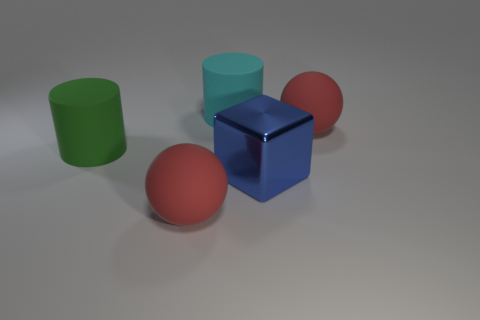There is a red sphere to the right of the big red object to the left of the blue cube; how big is it?
Offer a very short reply. Large. What color is the big thing that is right of the large cyan matte cylinder and behind the blue metal thing?
Offer a very short reply. Red. Is the shape of the green object the same as the big blue thing?
Provide a short and direct response. No. There is a matte thing that is left of the rubber ball that is in front of the block; what shape is it?
Your answer should be very brief. Cylinder. Is the shape of the cyan rubber object the same as the green object behind the blue cube?
Provide a short and direct response. Yes. There is a matte cylinder that is the same size as the cyan matte thing; what is its color?
Give a very brief answer. Green. Is the number of big balls that are left of the metal object less than the number of big rubber objects that are on the right side of the green cylinder?
Your answer should be very brief. Yes. What shape is the red rubber thing on the left side of the large sphere on the right side of the large red rubber sphere on the left side of the blue metal thing?
Provide a succinct answer. Sphere. Do the matte sphere that is right of the cyan cylinder and the thing in front of the blue block have the same color?
Offer a terse response. Yes. How many shiny things are large red spheres or big blocks?
Give a very brief answer. 1. 